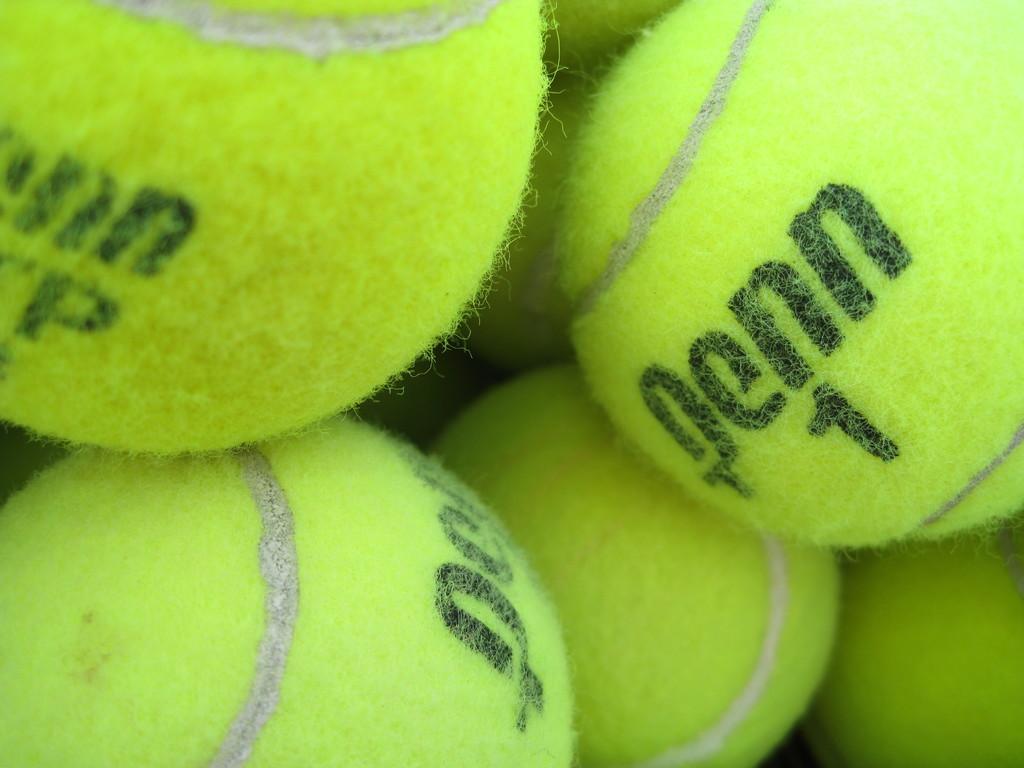In one or two sentences, can you explain what this image depicts? In this picture, I can see tennis balls and I can see some text on the balls and all the balls are green in color. 